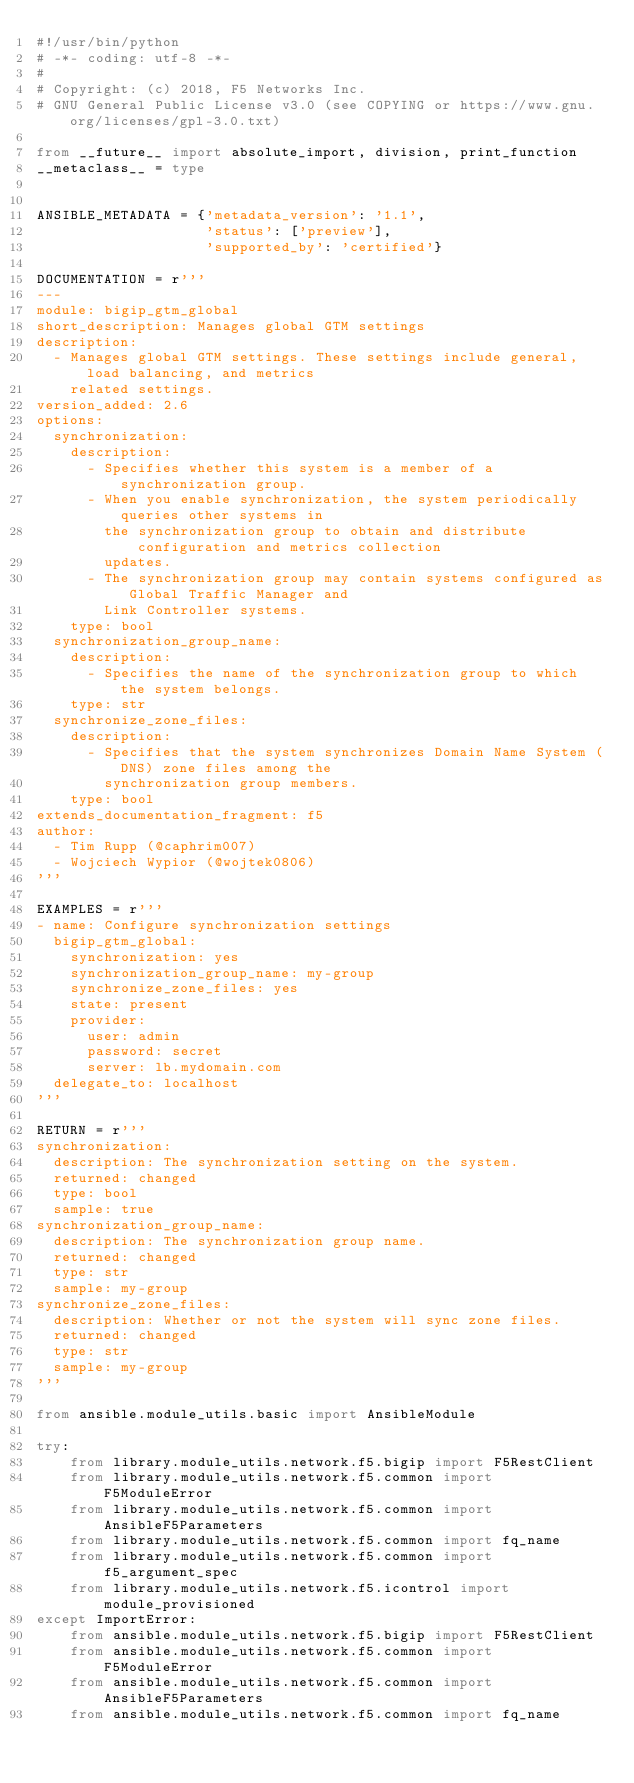Convert code to text. <code><loc_0><loc_0><loc_500><loc_500><_Python_>#!/usr/bin/python
# -*- coding: utf-8 -*-
#
# Copyright: (c) 2018, F5 Networks Inc.
# GNU General Public License v3.0 (see COPYING or https://www.gnu.org/licenses/gpl-3.0.txt)

from __future__ import absolute_import, division, print_function
__metaclass__ = type


ANSIBLE_METADATA = {'metadata_version': '1.1',
                    'status': ['preview'],
                    'supported_by': 'certified'}

DOCUMENTATION = r'''
---
module: bigip_gtm_global
short_description: Manages global GTM settings
description:
  - Manages global GTM settings. These settings include general, load balancing, and metrics
    related settings.
version_added: 2.6
options:
  synchronization:
    description:
      - Specifies whether this system is a member of a synchronization group.
      - When you enable synchronization, the system periodically queries other systems in
        the synchronization group to obtain and distribute configuration and metrics collection
        updates.
      - The synchronization group may contain systems configured as Global Traffic Manager and
        Link Controller systems.
    type: bool
  synchronization_group_name:
    description:
      - Specifies the name of the synchronization group to which the system belongs.
    type: str
  synchronize_zone_files:
    description:
      - Specifies that the system synchronizes Domain Name System (DNS) zone files among the
        synchronization group members.
    type: bool
extends_documentation_fragment: f5
author:
  - Tim Rupp (@caphrim007)
  - Wojciech Wypior (@wojtek0806)
'''

EXAMPLES = r'''
- name: Configure synchronization settings
  bigip_gtm_global:
    synchronization: yes
    synchronization_group_name: my-group
    synchronize_zone_files: yes
    state: present
    provider:
      user: admin
      password: secret
      server: lb.mydomain.com
  delegate_to: localhost
'''

RETURN = r'''
synchronization:
  description: The synchronization setting on the system.
  returned: changed
  type: bool
  sample: true
synchronization_group_name:
  description: The synchronization group name.
  returned: changed
  type: str
  sample: my-group
synchronize_zone_files:
  description: Whether or not the system will sync zone files.
  returned: changed
  type: str
  sample: my-group
'''

from ansible.module_utils.basic import AnsibleModule

try:
    from library.module_utils.network.f5.bigip import F5RestClient
    from library.module_utils.network.f5.common import F5ModuleError
    from library.module_utils.network.f5.common import AnsibleF5Parameters
    from library.module_utils.network.f5.common import fq_name
    from library.module_utils.network.f5.common import f5_argument_spec
    from library.module_utils.network.f5.icontrol import module_provisioned
except ImportError:
    from ansible.module_utils.network.f5.bigip import F5RestClient
    from ansible.module_utils.network.f5.common import F5ModuleError
    from ansible.module_utils.network.f5.common import AnsibleF5Parameters
    from ansible.module_utils.network.f5.common import fq_name</code> 